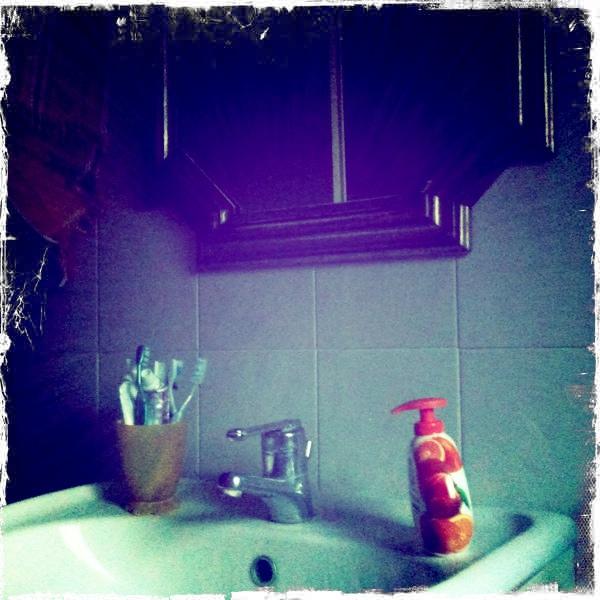Is the room dark?
Quick response, please. Yes. Is the faucet working?
Answer briefly. Yes. What room is this?
Write a very short answer. Bathroom. 